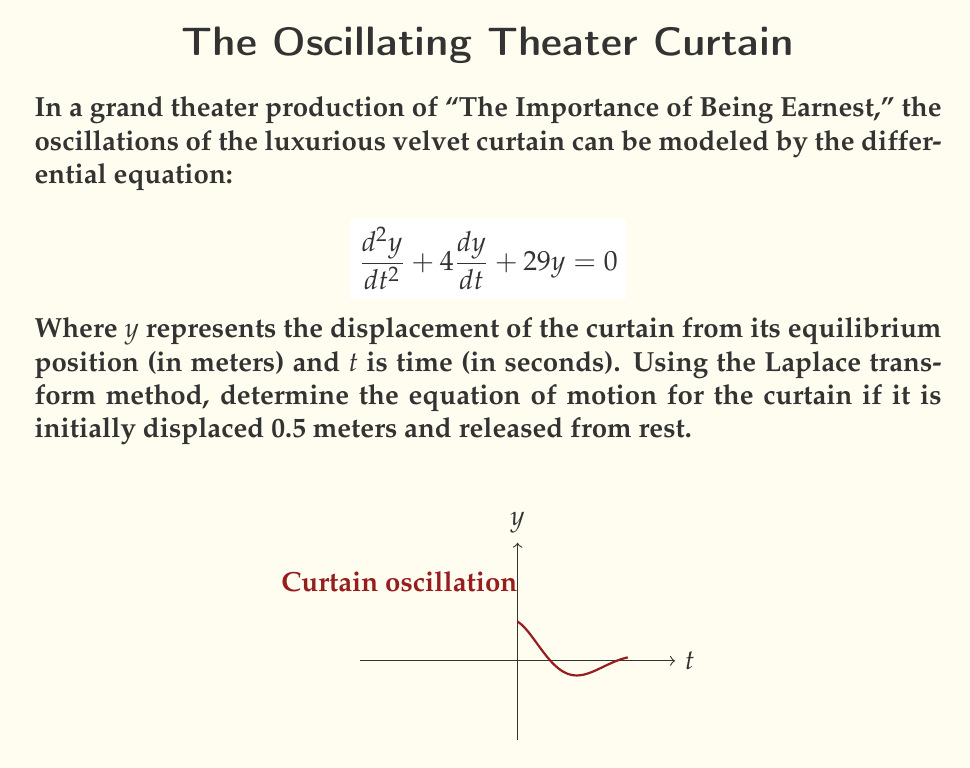Solve this math problem. Let's solve this step-by-step using the Laplace transform method:

1) First, we take the Laplace transform of both sides of the differential equation:

   $$\mathcal{L}\left\{\frac{d^2y}{dt^2} + 4\frac{dy}{dt} + 29y\right\} = \mathcal{L}\{0\}$$

2) Using Laplace transform properties:

   $$s^2Y(s) - sy(0) - y'(0) + 4[sY(s) - y(0)] + 29Y(s) = 0$$

3) Given initial conditions: $y(0) = 0.5$ and $y'(0) = 0$

   $$s^2Y(s) - 0.5s + 4sY(s) - 2 + 29Y(s) = 0$$

4) Collect terms with $Y(s)$:

   $$(s^2 + 4s + 29)Y(s) = 0.5s + 2$$

5) Solve for $Y(s)$:

   $$Y(s) = \frac{0.5s + 2}{s^2 + 4s + 29}$$

6) This can be rewritten as:

   $$Y(s) = \frac{0.5s + 2}{(s+2)^2 + 25}$$

7) This is in the form of the Laplace transform of a damped cosine function:

   $$\mathcal{L}^{-1}\left\{\frac{a + bs}{(s+\alpha)^2 + \beta^2}\right\} = e^{-\alpha t}\left(\frac{a}{\beta}\sin(\beta t) + b\cos(\beta t)\right)$$

8) In our case, $\alpha = 2$, $\beta = 5$, $a = 2$, and $b = 0.5$

9) Taking the inverse Laplace transform:

   $$y(t) = e^{-2t}\left(\frac{2}{5}\sin(5t) + 0.5\cos(5t)\right)$$

This is the equation of motion for the curtain.
Answer: $y(t) = e^{-2t}\left(\frac{2}{5}\sin(5t) + 0.5\cos(5t)\right)$ 